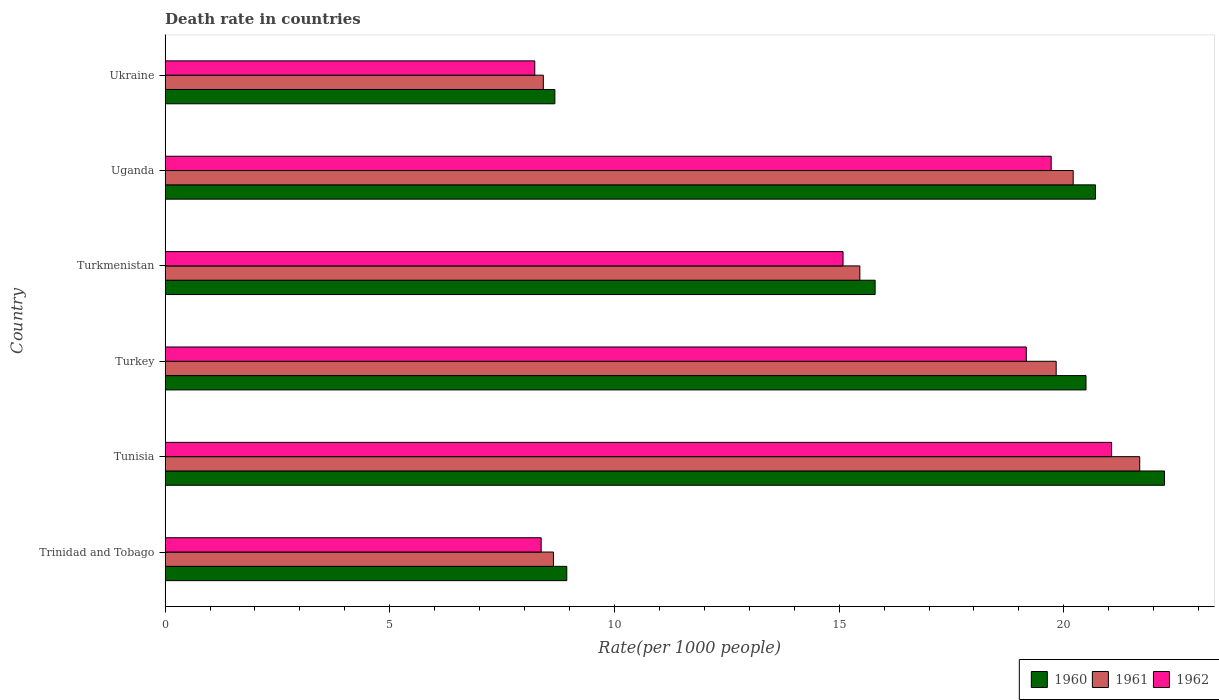Are the number of bars on each tick of the Y-axis equal?
Your response must be concise. Yes. How many bars are there on the 2nd tick from the top?
Keep it short and to the point. 3. What is the label of the 3rd group of bars from the top?
Give a very brief answer. Turkmenistan. In how many cases, is the number of bars for a given country not equal to the number of legend labels?
Keep it short and to the point. 0. What is the death rate in 1961 in Tunisia?
Offer a terse response. 21.69. Across all countries, what is the maximum death rate in 1960?
Keep it short and to the point. 22.24. Across all countries, what is the minimum death rate in 1960?
Provide a succinct answer. 8.67. In which country was the death rate in 1960 maximum?
Offer a terse response. Tunisia. In which country was the death rate in 1961 minimum?
Provide a succinct answer. Ukraine. What is the total death rate in 1961 in the graph?
Make the answer very short. 94.25. What is the difference between the death rate in 1960 in Tunisia and that in Turkmenistan?
Offer a terse response. 6.44. What is the difference between the death rate in 1962 in Turkmenistan and the death rate in 1960 in Turkey?
Your answer should be compact. -5.41. What is the average death rate in 1962 per country?
Your answer should be compact. 15.27. What is the difference between the death rate in 1961 and death rate in 1960 in Turkey?
Your answer should be very brief. -0.66. In how many countries, is the death rate in 1960 greater than 9 ?
Offer a very short reply. 4. What is the ratio of the death rate in 1960 in Trinidad and Tobago to that in Turkey?
Ensure brevity in your answer.  0.44. Is the death rate in 1960 in Turkey less than that in Ukraine?
Offer a terse response. No. What is the difference between the highest and the second highest death rate in 1960?
Keep it short and to the point. 1.54. What is the difference between the highest and the lowest death rate in 1962?
Offer a terse response. 12.84. In how many countries, is the death rate in 1960 greater than the average death rate in 1960 taken over all countries?
Keep it short and to the point. 3. Is it the case that in every country, the sum of the death rate in 1962 and death rate in 1961 is greater than the death rate in 1960?
Make the answer very short. Yes. Are all the bars in the graph horizontal?
Offer a very short reply. Yes. What is the difference between two consecutive major ticks on the X-axis?
Offer a very short reply. 5. Are the values on the major ticks of X-axis written in scientific E-notation?
Keep it short and to the point. No. Does the graph contain grids?
Provide a short and direct response. No. How are the legend labels stacked?
Offer a very short reply. Horizontal. What is the title of the graph?
Your response must be concise. Death rate in countries. What is the label or title of the X-axis?
Offer a terse response. Rate(per 1000 people). What is the Rate(per 1000 people) in 1960 in Trinidad and Tobago?
Keep it short and to the point. 8.94. What is the Rate(per 1000 people) of 1961 in Trinidad and Tobago?
Keep it short and to the point. 8.64. What is the Rate(per 1000 people) of 1962 in Trinidad and Tobago?
Your answer should be compact. 8.37. What is the Rate(per 1000 people) in 1960 in Tunisia?
Provide a short and direct response. 22.24. What is the Rate(per 1000 people) in 1961 in Tunisia?
Offer a very short reply. 21.69. What is the Rate(per 1000 people) in 1962 in Tunisia?
Ensure brevity in your answer.  21.06. What is the Rate(per 1000 people) of 1960 in Turkey?
Offer a terse response. 20.49. What is the Rate(per 1000 people) in 1961 in Turkey?
Ensure brevity in your answer.  19.83. What is the Rate(per 1000 people) in 1962 in Turkey?
Your response must be concise. 19.16. What is the Rate(per 1000 people) of 1960 in Turkmenistan?
Provide a succinct answer. 15.8. What is the Rate(per 1000 people) in 1961 in Turkmenistan?
Your answer should be compact. 15.46. What is the Rate(per 1000 people) of 1962 in Turkmenistan?
Offer a very short reply. 15.09. What is the Rate(per 1000 people) of 1960 in Uganda?
Your response must be concise. 20.7. What is the Rate(per 1000 people) in 1961 in Uganda?
Make the answer very short. 20.21. What is the Rate(per 1000 people) of 1962 in Uganda?
Your response must be concise. 19.72. What is the Rate(per 1000 people) in 1960 in Ukraine?
Provide a short and direct response. 8.67. What is the Rate(per 1000 people) of 1961 in Ukraine?
Keep it short and to the point. 8.42. What is the Rate(per 1000 people) in 1962 in Ukraine?
Give a very brief answer. 8.23. Across all countries, what is the maximum Rate(per 1000 people) in 1960?
Give a very brief answer. 22.24. Across all countries, what is the maximum Rate(per 1000 people) in 1961?
Ensure brevity in your answer.  21.69. Across all countries, what is the maximum Rate(per 1000 people) of 1962?
Offer a terse response. 21.06. Across all countries, what is the minimum Rate(per 1000 people) of 1960?
Provide a short and direct response. 8.67. Across all countries, what is the minimum Rate(per 1000 people) in 1961?
Make the answer very short. 8.42. Across all countries, what is the minimum Rate(per 1000 people) of 1962?
Your answer should be compact. 8.23. What is the total Rate(per 1000 people) in 1960 in the graph?
Provide a succinct answer. 96.85. What is the total Rate(per 1000 people) in 1961 in the graph?
Offer a terse response. 94.25. What is the total Rate(per 1000 people) in 1962 in the graph?
Provide a succinct answer. 91.63. What is the difference between the Rate(per 1000 people) in 1960 in Trinidad and Tobago and that in Tunisia?
Offer a terse response. -13.3. What is the difference between the Rate(per 1000 people) in 1961 in Trinidad and Tobago and that in Tunisia?
Keep it short and to the point. -13.05. What is the difference between the Rate(per 1000 people) in 1962 in Trinidad and Tobago and that in Tunisia?
Make the answer very short. -12.69. What is the difference between the Rate(per 1000 people) of 1960 in Trinidad and Tobago and that in Turkey?
Offer a very short reply. -11.55. What is the difference between the Rate(per 1000 people) of 1961 in Trinidad and Tobago and that in Turkey?
Your answer should be very brief. -11.19. What is the difference between the Rate(per 1000 people) in 1962 in Trinidad and Tobago and that in Turkey?
Offer a very short reply. -10.8. What is the difference between the Rate(per 1000 people) of 1960 in Trinidad and Tobago and that in Turkmenistan?
Offer a very short reply. -6.86. What is the difference between the Rate(per 1000 people) in 1961 in Trinidad and Tobago and that in Turkmenistan?
Your answer should be compact. -6.82. What is the difference between the Rate(per 1000 people) in 1962 in Trinidad and Tobago and that in Turkmenistan?
Keep it short and to the point. -6.72. What is the difference between the Rate(per 1000 people) in 1960 in Trinidad and Tobago and that in Uganda?
Give a very brief answer. -11.77. What is the difference between the Rate(per 1000 people) in 1961 in Trinidad and Tobago and that in Uganda?
Ensure brevity in your answer.  -11.57. What is the difference between the Rate(per 1000 people) in 1962 in Trinidad and Tobago and that in Uganda?
Offer a terse response. -11.35. What is the difference between the Rate(per 1000 people) of 1960 in Trinidad and Tobago and that in Ukraine?
Give a very brief answer. 0.27. What is the difference between the Rate(per 1000 people) of 1961 in Trinidad and Tobago and that in Ukraine?
Give a very brief answer. 0.23. What is the difference between the Rate(per 1000 people) in 1962 in Trinidad and Tobago and that in Ukraine?
Provide a succinct answer. 0.14. What is the difference between the Rate(per 1000 people) in 1960 in Tunisia and that in Turkey?
Ensure brevity in your answer.  1.75. What is the difference between the Rate(per 1000 people) of 1961 in Tunisia and that in Turkey?
Make the answer very short. 1.86. What is the difference between the Rate(per 1000 people) of 1962 in Tunisia and that in Turkey?
Your answer should be very brief. 1.9. What is the difference between the Rate(per 1000 people) in 1960 in Tunisia and that in Turkmenistan?
Keep it short and to the point. 6.44. What is the difference between the Rate(per 1000 people) of 1961 in Tunisia and that in Turkmenistan?
Ensure brevity in your answer.  6.23. What is the difference between the Rate(per 1000 people) of 1962 in Tunisia and that in Turkmenistan?
Keep it short and to the point. 5.98. What is the difference between the Rate(per 1000 people) of 1960 in Tunisia and that in Uganda?
Give a very brief answer. 1.54. What is the difference between the Rate(per 1000 people) in 1961 in Tunisia and that in Uganda?
Ensure brevity in your answer.  1.48. What is the difference between the Rate(per 1000 people) of 1962 in Tunisia and that in Uganda?
Your answer should be compact. 1.34. What is the difference between the Rate(per 1000 people) in 1960 in Tunisia and that in Ukraine?
Give a very brief answer. 13.57. What is the difference between the Rate(per 1000 people) of 1961 in Tunisia and that in Ukraine?
Ensure brevity in your answer.  13.27. What is the difference between the Rate(per 1000 people) in 1962 in Tunisia and that in Ukraine?
Keep it short and to the point. 12.84. What is the difference between the Rate(per 1000 people) in 1960 in Turkey and that in Turkmenistan?
Keep it short and to the point. 4.69. What is the difference between the Rate(per 1000 people) of 1961 in Turkey and that in Turkmenistan?
Provide a succinct answer. 4.37. What is the difference between the Rate(per 1000 people) in 1962 in Turkey and that in Turkmenistan?
Make the answer very short. 4.08. What is the difference between the Rate(per 1000 people) of 1960 in Turkey and that in Uganda?
Provide a succinct answer. -0.21. What is the difference between the Rate(per 1000 people) of 1961 in Turkey and that in Uganda?
Provide a short and direct response. -0.38. What is the difference between the Rate(per 1000 people) of 1962 in Turkey and that in Uganda?
Your answer should be very brief. -0.55. What is the difference between the Rate(per 1000 people) in 1960 in Turkey and that in Ukraine?
Your answer should be very brief. 11.82. What is the difference between the Rate(per 1000 people) in 1961 in Turkey and that in Ukraine?
Your answer should be compact. 11.41. What is the difference between the Rate(per 1000 people) in 1962 in Turkey and that in Ukraine?
Give a very brief answer. 10.94. What is the difference between the Rate(per 1000 people) in 1960 in Turkmenistan and that in Uganda?
Provide a short and direct response. -4.9. What is the difference between the Rate(per 1000 people) of 1961 in Turkmenistan and that in Uganda?
Offer a very short reply. -4.75. What is the difference between the Rate(per 1000 people) of 1962 in Turkmenistan and that in Uganda?
Ensure brevity in your answer.  -4.63. What is the difference between the Rate(per 1000 people) in 1960 in Turkmenistan and that in Ukraine?
Provide a succinct answer. 7.13. What is the difference between the Rate(per 1000 people) of 1961 in Turkmenistan and that in Ukraine?
Your answer should be compact. 7.04. What is the difference between the Rate(per 1000 people) in 1962 in Turkmenistan and that in Ukraine?
Offer a very short reply. 6.86. What is the difference between the Rate(per 1000 people) in 1960 in Uganda and that in Ukraine?
Provide a short and direct response. 12.03. What is the difference between the Rate(per 1000 people) in 1961 in Uganda and that in Ukraine?
Ensure brevity in your answer.  11.79. What is the difference between the Rate(per 1000 people) of 1962 in Uganda and that in Ukraine?
Make the answer very short. 11.49. What is the difference between the Rate(per 1000 people) of 1960 in Trinidad and Tobago and the Rate(per 1000 people) of 1961 in Tunisia?
Your answer should be compact. -12.75. What is the difference between the Rate(per 1000 people) in 1960 in Trinidad and Tobago and the Rate(per 1000 people) in 1962 in Tunisia?
Your response must be concise. -12.12. What is the difference between the Rate(per 1000 people) in 1961 in Trinidad and Tobago and the Rate(per 1000 people) in 1962 in Tunisia?
Ensure brevity in your answer.  -12.42. What is the difference between the Rate(per 1000 people) in 1960 in Trinidad and Tobago and the Rate(per 1000 people) in 1961 in Turkey?
Make the answer very short. -10.89. What is the difference between the Rate(per 1000 people) of 1960 in Trinidad and Tobago and the Rate(per 1000 people) of 1962 in Turkey?
Your answer should be compact. -10.23. What is the difference between the Rate(per 1000 people) of 1961 in Trinidad and Tobago and the Rate(per 1000 people) of 1962 in Turkey?
Your answer should be very brief. -10.52. What is the difference between the Rate(per 1000 people) in 1960 in Trinidad and Tobago and the Rate(per 1000 people) in 1961 in Turkmenistan?
Ensure brevity in your answer.  -6.52. What is the difference between the Rate(per 1000 people) of 1960 in Trinidad and Tobago and the Rate(per 1000 people) of 1962 in Turkmenistan?
Make the answer very short. -6.15. What is the difference between the Rate(per 1000 people) in 1961 in Trinidad and Tobago and the Rate(per 1000 people) in 1962 in Turkmenistan?
Offer a terse response. -6.45. What is the difference between the Rate(per 1000 people) of 1960 in Trinidad and Tobago and the Rate(per 1000 people) of 1961 in Uganda?
Offer a terse response. -11.27. What is the difference between the Rate(per 1000 people) of 1960 in Trinidad and Tobago and the Rate(per 1000 people) of 1962 in Uganda?
Offer a very short reply. -10.78. What is the difference between the Rate(per 1000 people) in 1961 in Trinidad and Tobago and the Rate(per 1000 people) in 1962 in Uganda?
Your response must be concise. -11.08. What is the difference between the Rate(per 1000 people) of 1960 in Trinidad and Tobago and the Rate(per 1000 people) of 1961 in Ukraine?
Ensure brevity in your answer.  0.52. What is the difference between the Rate(per 1000 people) of 1960 in Trinidad and Tobago and the Rate(per 1000 people) of 1962 in Ukraine?
Keep it short and to the point. 0.71. What is the difference between the Rate(per 1000 people) in 1961 in Trinidad and Tobago and the Rate(per 1000 people) in 1962 in Ukraine?
Keep it short and to the point. 0.41. What is the difference between the Rate(per 1000 people) in 1960 in Tunisia and the Rate(per 1000 people) in 1961 in Turkey?
Provide a short and direct response. 2.41. What is the difference between the Rate(per 1000 people) of 1960 in Tunisia and the Rate(per 1000 people) of 1962 in Turkey?
Your answer should be compact. 3.08. What is the difference between the Rate(per 1000 people) of 1961 in Tunisia and the Rate(per 1000 people) of 1962 in Turkey?
Offer a terse response. 2.52. What is the difference between the Rate(per 1000 people) in 1960 in Tunisia and the Rate(per 1000 people) in 1961 in Turkmenistan?
Your response must be concise. 6.78. What is the difference between the Rate(per 1000 people) in 1960 in Tunisia and the Rate(per 1000 people) in 1962 in Turkmenistan?
Make the answer very short. 7.15. What is the difference between the Rate(per 1000 people) of 1961 in Tunisia and the Rate(per 1000 people) of 1962 in Turkmenistan?
Make the answer very short. 6.6. What is the difference between the Rate(per 1000 people) in 1960 in Tunisia and the Rate(per 1000 people) in 1961 in Uganda?
Offer a terse response. 2.03. What is the difference between the Rate(per 1000 people) of 1960 in Tunisia and the Rate(per 1000 people) of 1962 in Uganda?
Provide a succinct answer. 2.52. What is the difference between the Rate(per 1000 people) in 1961 in Tunisia and the Rate(per 1000 people) in 1962 in Uganda?
Offer a very short reply. 1.97. What is the difference between the Rate(per 1000 people) of 1960 in Tunisia and the Rate(per 1000 people) of 1961 in Ukraine?
Your response must be concise. 13.82. What is the difference between the Rate(per 1000 people) of 1960 in Tunisia and the Rate(per 1000 people) of 1962 in Ukraine?
Your response must be concise. 14.01. What is the difference between the Rate(per 1000 people) in 1961 in Tunisia and the Rate(per 1000 people) in 1962 in Ukraine?
Offer a very short reply. 13.46. What is the difference between the Rate(per 1000 people) of 1960 in Turkey and the Rate(per 1000 people) of 1961 in Turkmenistan?
Offer a very short reply. 5.03. What is the difference between the Rate(per 1000 people) of 1960 in Turkey and the Rate(per 1000 people) of 1962 in Turkmenistan?
Offer a very short reply. 5.41. What is the difference between the Rate(per 1000 people) of 1961 in Turkey and the Rate(per 1000 people) of 1962 in Turkmenistan?
Offer a terse response. 4.74. What is the difference between the Rate(per 1000 people) of 1960 in Turkey and the Rate(per 1000 people) of 1961 in Uganda?
Your answer should be compact. 0.28. What is the difference between the Rate(per 1000 people) of 1960 in Turkey and the Rate(per 1000 people) of 1962 in Uganda?
Provide a succinct answer. 0.78. What is the difference between the Rate(per 1000 people) in 1961 in Turkey and the Rate(per 1000 people) in 1962 in Uganda?
Make the answer very short. 0.11. What is the difference between the Rate(per 1000 people) of 1960 in Turkey and the Rate(per 1000 people) of 1961 in Ukraine?
Provide a succinct answer. 12.08. What is the difference between the Rate(per 1000 people) in 1960 in Turkey and the Rate(per 1000 people) in 1962 in Ukraine?
Provide a succinct answer. 12.27. What is the difference between the Rate(per 1000 people) in 1961 in Turkey and the Rate(per 1000 people) in 1962 in Ukraine?
Your answer should be compact. 11.6. What is the difference between the Rate(per 1000 people) in 1960 in Turkmenistan and the Rate(per 1000 people) in 1961 in Uganda?
Offer a terse response. -4.41. What is the difference between the Rate(per 1000 people) in 1960 in Turkmenistan and the Rate(per 1000 people) in 1962 in Uganda?
Your response must be concise. -3.92. What is the difference between the Rate(per 1000 people) of 1961 in Turkmenistan and the Rate(per 1000 people) of 1962 in Uganda?
Keep it short and to the point. -4.26. What is the difference between the Rate(per 1000 people) in 1960 in Turkmenistan and the Rate(per 1000 people) in 1961 in Ukraine?
Make the answer very short. 7.38. What is the difference between the Rate(per 1000 people) in 1960 in Turkmenistan and the Rate(per 1000 people) in 1962 in Ukraine?
Give a very brief answer. 7.57. What is the difference between the Rate(per 1000 people) in 1961 in Turkmenistan and the Rate(per 1000 people) in 1962 in Ukraine?
Provide a succinct answer. 7.23. What is the difference between the Rate(per 1000 people) of 1960 in Uganda and the Rate(per 1000 people) of 1961 in Ukraine?
Offer a very short reply. 12.29. What is the difference between the Rate(per 1000 people) in 1960 in Uganda and the Rate(per 1000 people) in 1962 in Ukraine?
Offer a very short reply. 12.48. What is the difference between the Rate(per 1000 people) of 1961 in Uganda and the Rate(per 1000 people) of 1962 in Ukraine?
Provide a succinct answer. 11.98. What is the average Rate(per 1000 people) in 1960 per country?
Your answer should be compact. 16.14. What is the average Rate(per 1000 people) in 1961 per country?
Make the answer very short. 15.71. What is the average Rate(per 1000 people) in 1962 per country?
Make the answer very short. 15.27. What is the difference between the Rate(per 1000 people) in 1960 and Rate(per 1000 people) in 1961 in Trinidad and Tobago?
Your answer should be very brief. 0.3. What is the difference between the Rate(per 1000 people) of 1960 and Rate(per 1000 people) of 1962 in Trinidad and Tobago?
Provide a short and direct response. 0.57. What is the difference between the Rate(per 1000 people) in 1961 and Rate(per 1000 people) in 1962 in Trinidad and Tobago?
Keep it short and to the point. 0.27. What is the difference between the Rate(per 1000 people) in 1960 and Rate(per 1000 people) in 1961 in Tunisia?
Offer a very short reply. 0.55. What is the difference between the Rate(per 1000 people) of 1960 and Rate(per 1000 people) of 1962 in Tunisia?
Make the answer very short. 1.18. What is the difference between the Rate(per 1000 people) of 1961 and Rate(per 1000 people) of 1962 in Tunisia?
Make the answer very short. 0.63. What is the difference between the Rate(per 1000 people) of 1960 and Rate(per 1000 people) of 1961 in Turkey?
Your answer should be very brief. 0.66. What is the difference between the Rate(per 1000 people) in 1960 and Rate(per 1000 people) in 1962 in Turkey?
Your answer should be very brief. 1.33. What is the difference between the Rate(per 1000 people) of 1961 and Rate(per 1000 people) of 1962 in Turkey?
Ensure brevity in your answer.  0.67. What is the difference between the Rate(per 1000 people) of 1960 and Rate(per 1000 people) of 1961 in Turkmenistan?
Ensure brevity in your answer.  0.34. What is the difference between the Rate(per 1000 people) in 1960 and Rate(per 1000 people) in 1962 in Turkmenistan?
Your answer should be compact. 0.71. What is the difference between the Rate(per 1000 people) of 1961 and Rate(per 1000 people) of 1962 in Turkmenistan?
Your response must be concise. 0.37. What is the difference between the Rate(per 1000 people) in 1960 and Rate(per 1000 people) in 1961 in Uganda?
Your answer should be very brief. 0.49. What is the difference between the Rate(per 1000 people) of 1961 and Rate(per 1000 people) of 1962 in Uganda?
Ensure brevity in your answer.  0.49. What is the difference between the Rate(per 1000 people) in 1960 and Rate(per 1000 people) in 1961 in Ukraine?
Keep it short and to the point. 0.26. What is the difference between the Rate(per 1000 people) in 1960 and Rate(per 1000 people) in 1962 in Ukraine?
Give a very brief answer. 0.45. What is the difference between the Rate(per 1000 people) in 1961 and Rate(per 1000 people) in 1962 in Ukraine?
Your response must be concise. 0.19. What is the ratio of the Rate(per 1000 people) in 1960 in Trinidad and Tobago to that in Tunisia?
Your response must be concise. 0.4. What is the ratio of the Rate(per 1000 people) in 1961 in Trinidad and Tobago to that in Tunisia?
Your response must be concise. 0.4. What is the ratio of the Rate(per 1000 people) in 1962 in Trinidad and Tobago to that in Tunisia?
Provide a short and direct response. 0.4. What is the ratio of the Rate(per 1000 people) of 1960 in Trinidad and Tobago to that in Turkey?
Make the answer very short. 0.44. What is the ratio of the Rate(per 1000 people) of 1961 in Trinidad and Tobago to that in Turkey?
Your response must be concise. 0.44. What is the ratio of the Rate(per 1000 people) in 1962 in Trinidad and Tobago to that in Turkey?
Ensure brevity in your answer.  0.44. What is the ratio of the Rate(per 1000 people) of 1960 in Trinidad and Tobago to that in Turkmenistan?
Provide a short and direct response. 0.57. What is the ratio of the Rate(per 1000 people) in 1961 in Trinidad and Tobago to that in Turkmenistan?
Your answer should be very brief. 0.56. What is the ratio of the Rate(per 1000 people) in 1962 in Trinidad and Tobago to that in Turkmenistan?
Offer a terse response. 0.55. What is the ratio of the Rate(per 1000 people) in 1960 in Trinidad and Tobago to that in Uganda?
Offer a terse response. 0.43. What is the ratio of the Rate(per 1000 people) of 1961 in Trinidad and Tobago to that in Uganda?
Ensure brevity in your answer.  0.43. What is the ratio of the Rate(per 1000 people) in 1962 in Trinidad and Tobago to that in Uganda?
Your response must be concise. 0.42. What is the ratio of the Rate(per 1000 people) of 1960 in Trinidad and Tobago to that in Ukraine?
Provide a succinct answer. 1.03. What is the ratio of the Rate(per 1000 people) of 1961 in Trinidad and Tobago to that in Ukraine?
Provide a succinct answer. 1.03. What is the ratio of the Rate(per 1000 people) of 1962 in Trinidad and Tobago to that in Ukraine?
Offer a very short reply. 1.02. What is the ratio of the Rate(per 1000 people) of 1960 in Tunisia to that in Turkey?
Provide a short and direct response. 1.09. What is the ratio of the Rate(per 1000 people) of 1961 in Tunisia to that in Turkey?
Offer a very short reply. 1.09. What is the ratio of the Rate(per 1000 people) of 1962 in Tunisia to that in Turkey?
Your response must be concise. 1.1. What is the ratio of the Rate(per 1000 people) of 1960 in Tunisia to that in Turkmenistan?
Ensure brevity in your answer.  1.41. What is the ratio of the Rate(per 1000 people) of 1961 in Tunisia to that in Turkmenistan?
Offer a terse response. 1.4. What is the ratio of the Rate(per 1000 people) in 1962 in Tunisia to that in Turkmenistan?
Your answer should be very brief. 1.4. What is the ratio of the Rate(per 1000 people) of 1960 in Tunisia to that in Uganda?
Give a very brief answer. 1.07. What is the ratio of the Rate(per 1000 people) in 1961 in Tunisia to that in Uganda?
Keep it short and to the point. 1.07. What is the ratio of the Rate(per 1000 people) of 1962 in Tunisia to that in Uganda?
Your response must be concise. 1.07. What is the ratio of the Rate(per 1000 people) in 1960 in Tunisia to that in Ukraine?
Offer a terse response. 2.56. What is the ratio of the Rate(per 1000 people) of 1961 in Tunisia to that in Ukraine?
Give a very brief answer. 2.58. What is the ratio of the Rate(per 1000 people) in 1962 in Tunisia to that in Ukraine?
Your answer should be very brief. 2.56. What is the ratio of the Rate(per 1000 people) in 1960 in Turkey to that in Turkmenistan?
Keep it short and to the point. 1.3. What is the ratio of the Rate(per 1000 people) in 1961 in Turkey to that in Turkmenistan?
Provide a succinct answer. 1.28. What is the ratio of the Rate(per 1000 people) of 1962 in Turkey to that in Turkmenistan?
Keep it short and to the point. 1.27. What is the ratio of the Rate(per 1000 people) in 1961 in Turkey to that in Uganda?
Offer a very short reply. 0.98. What is the ratio of the Rate(per 1000 people) in 1962 in Turkey to that in Uganda?
Offer a very short reply. 0.97. What is the ratio of the Rate(per 1000 people) in 1960 in Turkey to that in Ukraine?
Provide a succinct answer. 2.36. What is the ratio of the Rate(per 1000 people) of 1961 in Turkey to that in Ukraine?
Make the answer very short. 2.36. What is the ratio of the Rate(per 1000 people) of 1962 in Turkey to that in Ukraine?
Keep it short and to the point. 2.33. What is the ratio of the Rate(per 1000 people) in 1960 in Turkmenistan to that in Uganda?
Provide a succinct answer. 0.76. What is the ratio of the Rate(per 1000 people) of 1961 in Turkmenistan to that in Uganda?
Make the answer very short. 0.77. What is the ratio of the Rate(per 1000 people) of 1962 in Turkmenistan to that in Uganda?
Ensure brevity in your answer.  0.77. What is the ratio of the Rate(per 1000 people) of 1960 in Turkmenistan to that in Ukraine?
Your response must be concise. 1.82. What is the ratio of the Rate(per 1000 people) of 1961 in Turkmenistan to that in Ukraine?
Your answer should be very brief. 1.84. What is the ratio of the Rate(per 1000 people) in 1962 in Turkmenistan to that in Ukraine?
Provide a short and direct response. 1.83. What is the ratio of the Rate(per 1000 people) in 1960 in Uganda to that in Ukraine?
Make the answer very short. 2.39. What is the ratio of the Rate(per 1000 people) in 1961 in Uganda to that in Ukraine?
Ensure brevity in your answer.  2.4. What is the ratio of the Rate(per 1000 people) in 1962 in Uganda to that in Ukraine?
Your answer should be compact. 2.4. What is the difference between the highest and the second highest Rate(per 1000 people) in 1960?
Your answer should be compact. 1.54. What is the difference between the highest and the second highest Rate(per 1000 people) of 1961?
Give a very brief answer. 1.48. What is the difference between the highest and the second highest Rate(per 1000 people) of 1962?
Ensure brevity in your answer.  1.34. What is the difference between the highest and the lowest Rate(per 1000 people) in 1960?
Your response must be concise. 13.57. What is the difference between the highest and the lowest Rate(per 1000 people) in 1961?
Keep it short and to the point. 13.27. What is the difference between the highest and the lowest Rate(per 1000 people) in 1962?
Offer a very short reply. 12.84. 